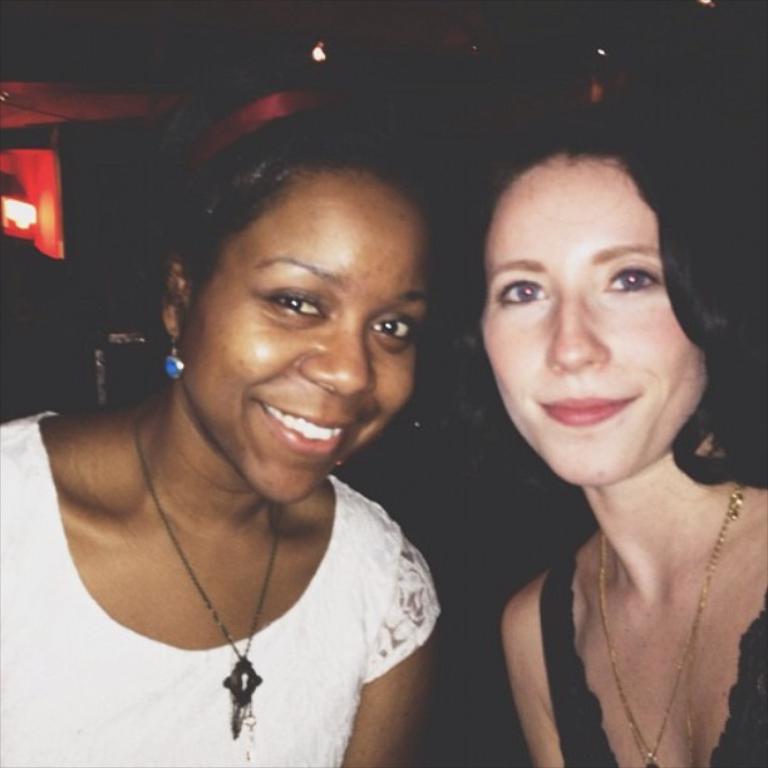In one or two sentences, can you explain what this image depicts? In this image there are two ladies. They both are smiling. The background is dark. 